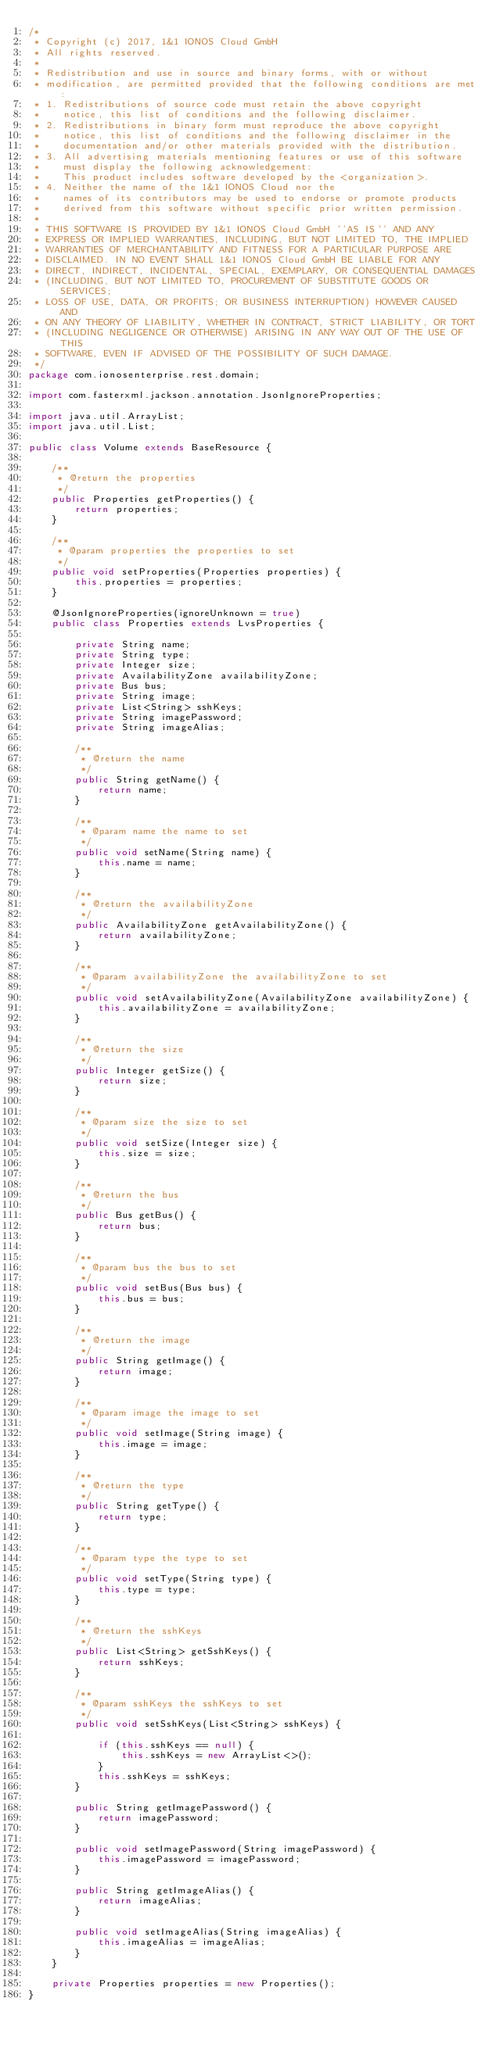<code> <loc_0><loc_0><loc_500><loc_500><_Java_>/*
 * Copyright (c) 2017, 1&1 IONOS Cloud GmbH
 * All rights reserved.
 *
 * Redistribution and use in source and binary forms, with or without
 * modification, are permitted provided that the following conditions are met:
 * 1. Redistributions of source code must retain the above copyright
 *    notice, this list of conditions and the following disclaimer.
 * 2. Redistributions in binary form must reproduce the above copyright
 *    notice, this list of conditions and the following disclaimer in the
 *    documentation and/or other materials provided with the distribution.
 * 3. All advertising materials mentioning features or use of this software
 *    must display the following acknowledgement:
 *    This product includes software developed by the <organization>.
 * 4. Neither the name of the 1&1 IONOS Cloud nor the
 *    names of its contributors may be used to endorse or promote products
 *    derived from this software without specific prior written permission.
 *
 * THIS SOFTWARE IS PROVIDED BY 1&1 IONOS Cloud GmbH ''AS IS'' AND ANY
 * EXPRESS OR IMPLIED WARRANTIES, INCLUDING, BUT NOT LIMITED TO, THE IMPLIED
 * WARRANTIES OF MERCHANTABILITY AND FITNESS FOR A PARTICULAR PURPOSE ARE
 * DISCLAIMED. IN NO EVENT SHALL 1&1 IONOS Cloud GmbH BE LIABLE FOR ANY
 * DIRECT, INDIRECT, INCIDENTAL, SPECIAL, EXEMPLARY, OR CONSEQUENTIAL DAMAGES
 * (INCLUDING, BUT NOT LIMITED TO, PROCUREMENT OF SUBSTITUTE GOODS OR SERVICES;
 * LOSS OF USE, DATA, OR PROFITS; OR BUSINESS INTERRUPTION) HOWEVER CAUSED AND
 * ON ANY THEORY OF LIABILITY, WHETHER IN CONTRACT, STRICT LIABILITY, OR TORT
 * (INCLUDING NEGLIGENCE OR OTHERWISE) ARISING IN ANY WAY OUT OF THE USE OF THIS
 * SOFTWARE, EVEN IF ADVISED OF THE POSSIBILITY OF SUCH DAMAGE.
 */
package com.ionosenterprise.rest.domain;

import com.fasterxml.jackson.annotation.JsonIgnoreProperties;

import java.util.ArrayList;
import java.util.List;

public class Volume extends BaseResource {

    /**
     * @return the properties
     */
    public Properties getProperties() {
        return properties;
    }

    /**
     * @param properties the properties to set
     */
    public void setProperties(Properties properties) {
        this.properties = properties;
    }

    @JsonIgnoreProperties(ignoreUnknown = true)
    public class Properties extends LvsProperties {

        private String name;
        private String type;
        private Integer size;
        private AvailabilityZone availabilityZone;
        private Bus bus;
        private String image;
        private List<String> sshKeys;
        private String imagePassword;
        private String imageAlias;

        /**
         * @return the name
         */
        public String getName() {
            return name;
        }

        /**
         * @param name the name to set
         */
        public void setName(String name) {
            this.name = name;
        }

        /**
         * @return the availabilityZone
         */
        public AvailabilityZone getAvailabilityZone() {
            return availabilityZone;
        }

        /**
         * @param availabilityZone the availabilityZone to set
         */
        public void setAvailabilityZone(AvailabilityZone availabilityZone) {
            this.availabilityZone = availabilityZone;
        }

        /**
         * @return the size
         */
        public Integer getSize() {
            return size;
        }

        /**
         * @param size the size to set
         */
        public void setSize(Integer size) {
            this.size = size;
        }

        /**
         * @return the bus
         */
        public Bus getBus() {
            return bus;
        }

        /**
         * @param bus the bus to set
         */
        public void setBus(Bus bus) {
            this.bus = bus;
        }

        /**
         * @return the image
         */
        public String getImage() {
            return image;
        }

        /**
         * @param image the image to set
         */
        public void setImage(String image) {
            this.image = image;
        }

        /**
         * @return the type
         */
        public String getType() {
            return type;
        }

        /**
         * @param type the type to set
         */
        public void setType(String type) {
            this.type = type;
        }

        /**
         * @return the sshKeys
         */
        public List<String> getSshKeys() {
            return sshKeys;
        }

        /**
         * @param sshKeys the sshKeys to set
         */
        public void setSshKeys(List<String> sshKeys) {

            if (this.sshKeys == null) {
                this.sshKeys = new ArrayList<>();
            }
            this.sshKeys = sshKeys;
        }

        public String getImagePassword() {
            return imagePassword;
        }

        public void setImagePassword(String imagePassword) {
            this.imagePassword = imagePassword;
        }

        public String getImageAlias() {
            return imageAlias;
        }

        public void setImageAlias(String imageAlias) {
            this.imageAlias = imageAlias;
        }
    }

    private Properties properties = new Properties();
}
</code> 